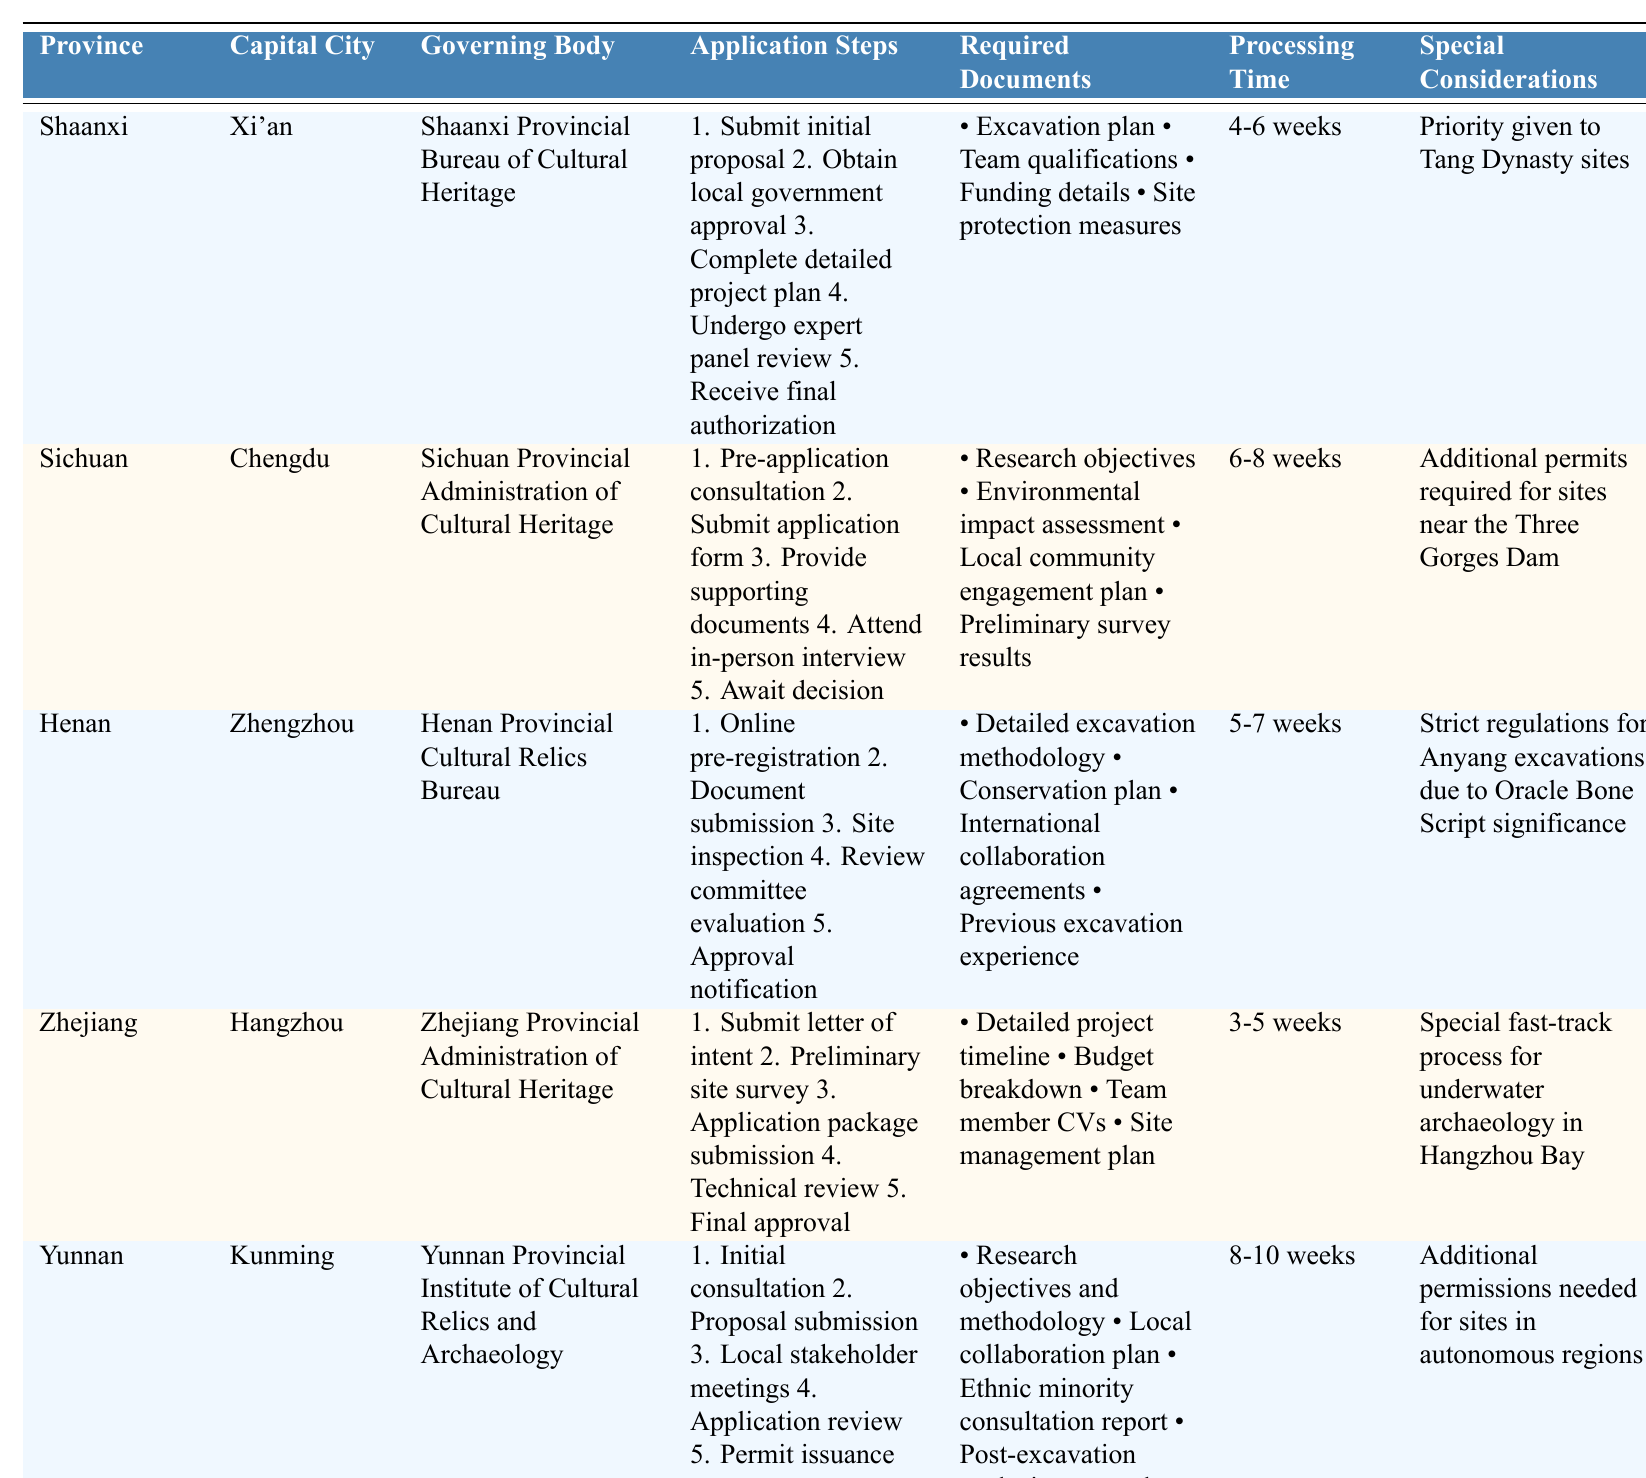What is the capital city of Henan? The table lists the capital city of Henan as Zhengzhou.
Answer: Zhengzhou How many steps are there in the Sichuan application process? The application steps for Sichuan are listed as five distinct points: pre-application consultation, submission of application form, provision of supporting documents, attendance in-person interview, and awaiting decision.
Answer: 5 Which province has the shortest processing time for permit applications? By comparing the processing times listed in the table, Zhejiang has the shortest processing time of 3-5 weeks.
Answer: Zhejiang Is there a special consideration mentioned for archaeological permits in Shaanxi? Yes, the table indicates that priority is given to Tang Dynasty sites when applying for permits in Shaanxi.
Answer: Yes What is the common requirement across all provinces for the permit application? Analyzing the required documents, it appears that a project-related plan or methodology is required across all provinces (e.g., excavation plan, research objectives, etc.).
Answer: Project-related plan Which province requires additional permits for sites near the Three Gorges Dam? The table specifies that Sichuan requires additional permits for sites located near the Three Gorges Dam.
Answer: Sichuan If you take the average length of processing times from the provinces listed, what is it? Processing times for Shaanxi (5), Sichuan (7), Henan (6), Zhejiang (4), and Yunnan (9) weeks can be averaged: (4+6+5+3+8)/5 = 5.2 weeks.
Answer: 5.2 weeks What steps must be completed after receiving the application's final approval in Shaanxi? The table shows that after the final authorization in Shaanxi, there are no further steps listed, indicating that the permit is complete once authorized.
Answer: None Which province requires a preliminary survey as part of the application process? The table indicates that Zhejiang requires a preliminary site survey during the application process.
Answer: Zhejiang What type of document is specifically requested for underwater archaeology in Zhejiang? The special consideration for Zhejiang mentions a fast-track process for underwater archaeology without specifying the document type; however, documents like a site management plan would be relevant.
Answer: Site management plan (implied, not expressly stated) 